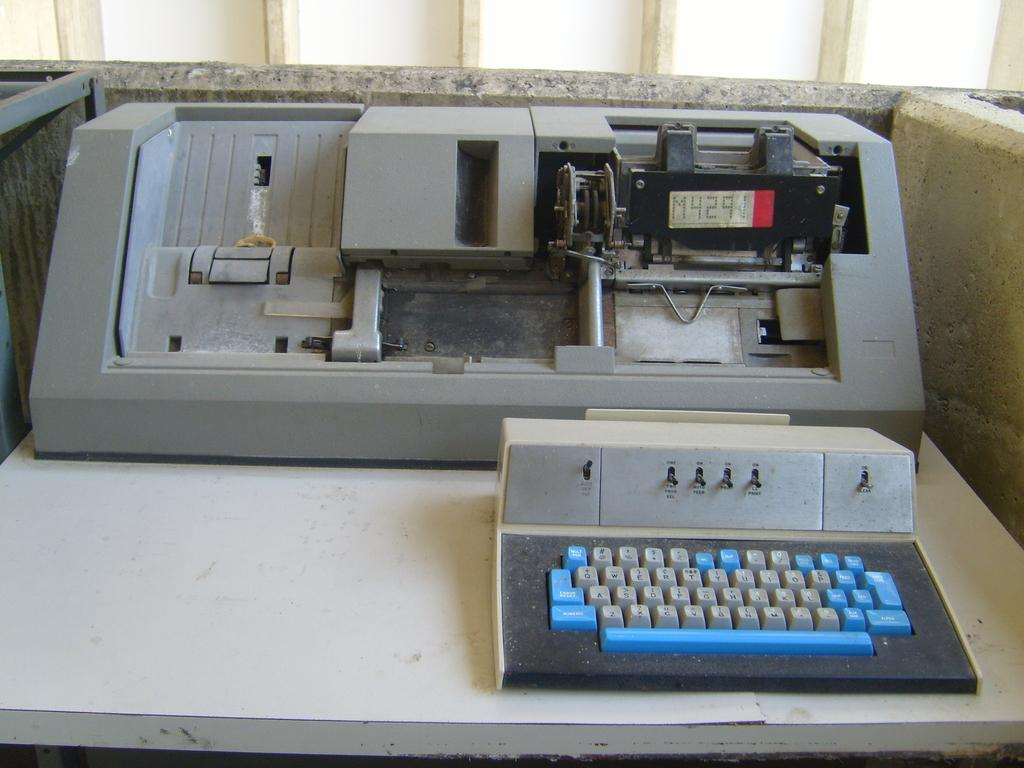Provide a one-sentence caption for the provided image. An old partially disassembled printer with the code M4291 showing on its display. 